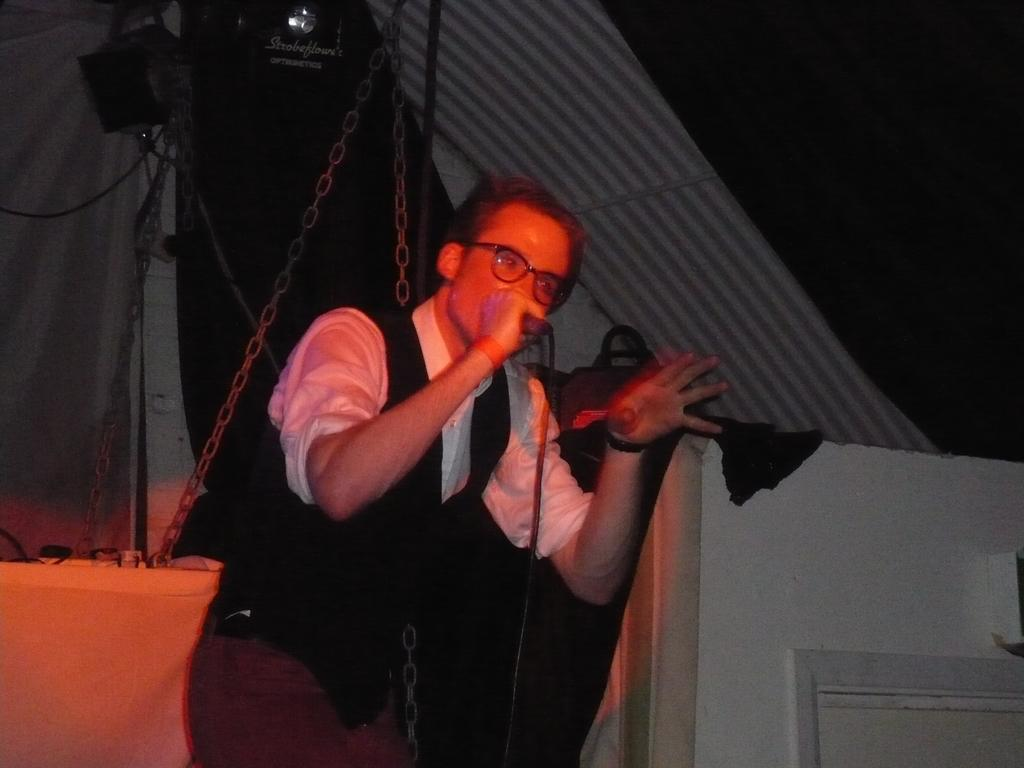What can be seen in the image? There is a person in the image. Can you describe the person's appearance? The person is wearing spectacles. What is the person holding in the image? The person is holding a microphone. What objects can be seen in the background of the image? There is a bag with some chains, speakers, lights, a tent, and the sky is visible in the background. What might be the purpose of the microphone and speakers in the image? The microphone and speakers suggest that the person might be giving a speech or performing at an event. What type of respect can be seen in the image? There is no specific type of respect visible in the image; it features a person holding a microphone and various objects in the background. What kind of work is the person doing in the image? The image does not provide enough information to determine the person's occupation or the specific work they are doing. 